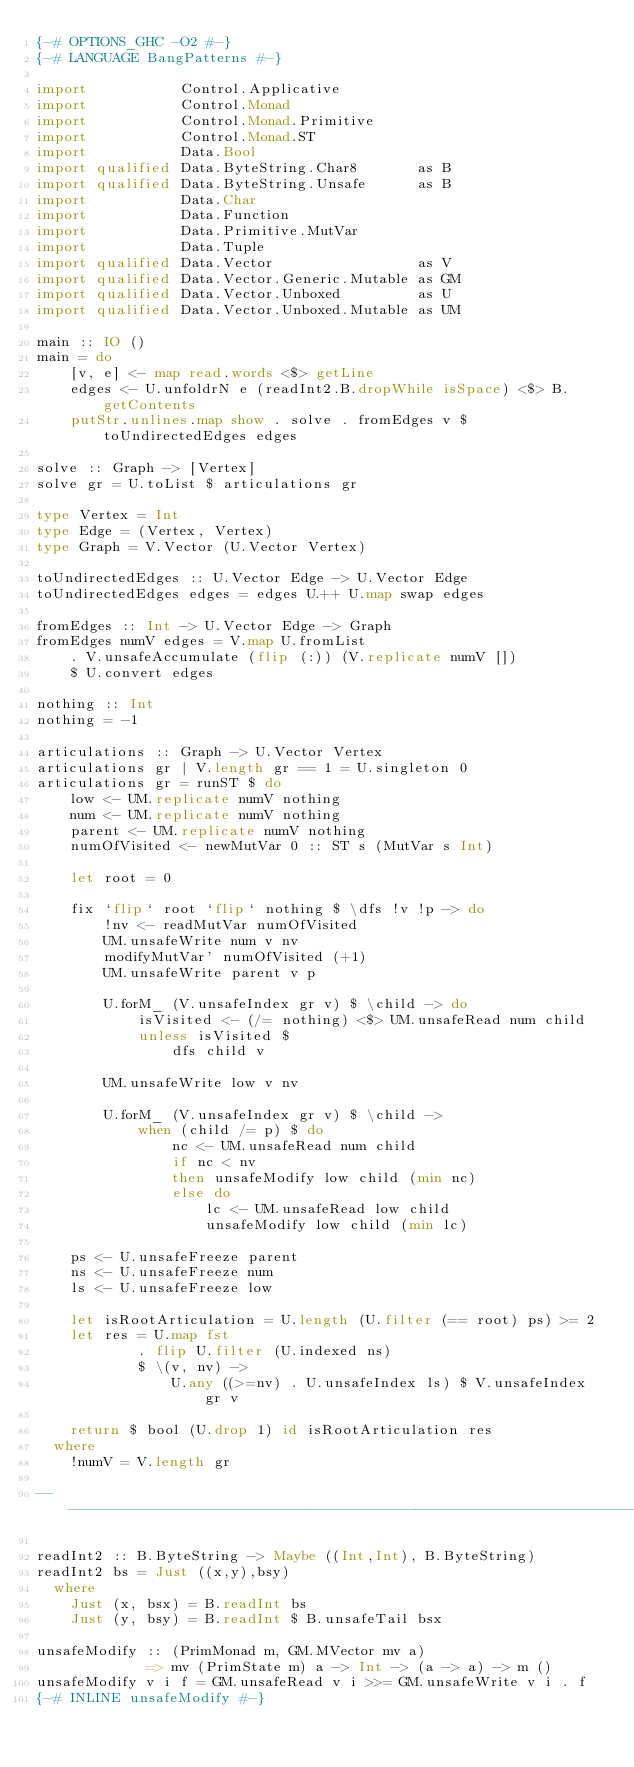Convert code to text. <code><loc_0><loc_0><loc_500><loc_500><_Haskell_>{-# OPTIONS_GHC -O2 #-}
{-# LANGUAGE BangPatterns #-}

import           Control.Applicative
import           Control.Monad
import           Control.Monad.Primitive
import           Control.Monad.ST
import           Data.Bool
import qualified Data.ByteString.Char8       as B
import qualified Data.ByteString.Unsafe      as B
import           Data.Char
import           Data.Function
import           Data.Primitive.MutVar
import           Data.Tuple
import qualified Data.Vector                 as V
import qualified Data.Vector.Generic.Mutable as GM
import qualified Data.Vector.Unboxed         as U
import qualified Data.Vector.Unboxed.Mutable as UM

main :: IO ()
main = do
    [v, e] <- map read.words <$> getLine
    edges <- U.unfoldrN e (readInt2.B.dropWhile isSpace) <$> B.getContents
    putStr.unlines.map show . solve . fromEdges v $ toUndirectedEdges edges

solve :: Graph -> [Vertex]
solve gr = U.toList $ articulations gr

type Vertex = Int
type Edge = (Vertex, Vertex)
type Graph = V.Vector (U.Vector Vertex)

toUndirectedEdges :: U.Vector Edge -> U.Vector Edge
toUndirectedEdges edges = edges U.++ U.map swap edges

fromEdges :: Int -> U.Vector Edge -> Graph
fromEdges numV edges = V.map U.fromList
    . V.unsafeAccumulate (flip (:)) (V.replicate numV [])
    $ U.convert edges

nothing :: Int
nothing = -1

articulations :: Graph -> U.Vector Vertex
articulations gr | V.length gr == 1 = U.singleton 0
articulations gr = runST $ do
    low <- UM.replicate numV nothing
    num <- UM.replicate numV nothing
    parent <- UM.replicate numV nothing
    numOfVisited <- newMutVar 0 :: ST s (MutVar s Int)

    let root = 0

    fix `flip` root `flip` nothing $ \dfs !v !p -> do
        !nv <- readMutVar numOfVisited
        UM.unsafeWrite num v nv
        modifyMutVar' numOfVisited (+1)
        UM.unsafeWrite parent v p

        U.forM_ (V.unsafeIndex gr v) $ \child -> do
            isVisited <- (/= nothing) <$> UM.unsafeRead num child
            unless isVisited $
                dfs child v

        UM.unsafeWrite low v nv

        U.forM_ (V.unsafeIndex gr v) $ \child ->
            when (child /= p) $ do
                nc <- UM.unsafeRead num child
                if nc < nv
                then unsafeModify low child (min nc)
                else do
                    lc <- UM.unsafeRead low child
                    unsafeModify low child (min lc)

    ps <- U.unsafeFreeze parent
    ns <- U.unsafeFreeze num
    ls <- U.unsafeFreeze low

    let isRootArticulation = U.length (U.filter (== root) ps) >= 2
    let res = U.map fst
            . flip U.filter (U.indexed ns)
            $ \(v, nv) ->
                U.any ((>=nv) . U.unsafeIndex ls) $ V.unsafeIndex gr v

    return $ bool (U.drop 1) id isRootArticulation res
  where
    !numV = V.length gr

-------------------------------------------------------------------------------

readInt2 :: B.ByteString -> Maybe ((Int,Int), B.ByteString)
readInt2 bs = Just ((x,y),bsy)
  where
    Just (x, bsx) = B.readInt bs
    Just (y, bsy) = B.readInt $ B.unsafeTail bsx

unsafeModify :: (PrimMonad m, GM.MVector mv a)
             => mv (PrimState m) a -> Int -> (a -> a) -> m ()
unsafeModify v i f = GM.unsafeRead v i >>= GM.unsafeWrite v i . f
{-# INLINE unsafeModify #-}</code> 